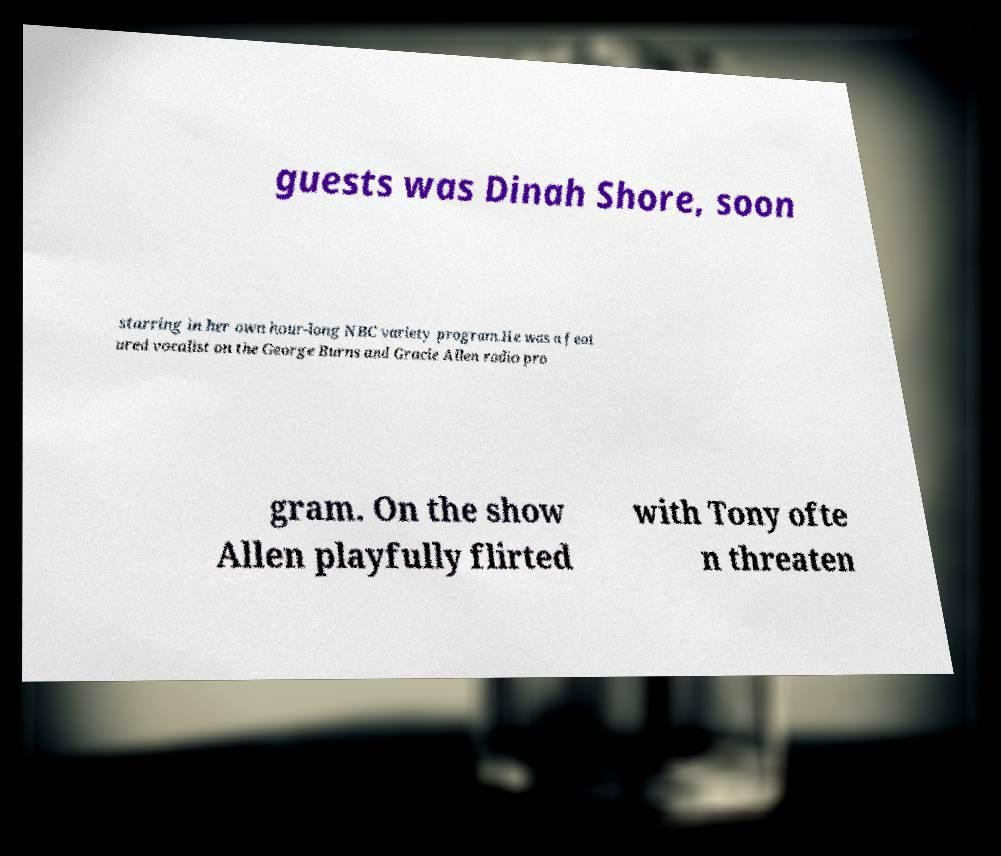Could you assist in decoding the text presented in this image and type it out clearly? guests was Dinah Shore, soon starring in her own hour-long NBC variety program.He was a feat ured vocalist on the George Burns and Gracie Allen radio pro gram. On the show Allen playfully flirted with Tony ofte n threaten 